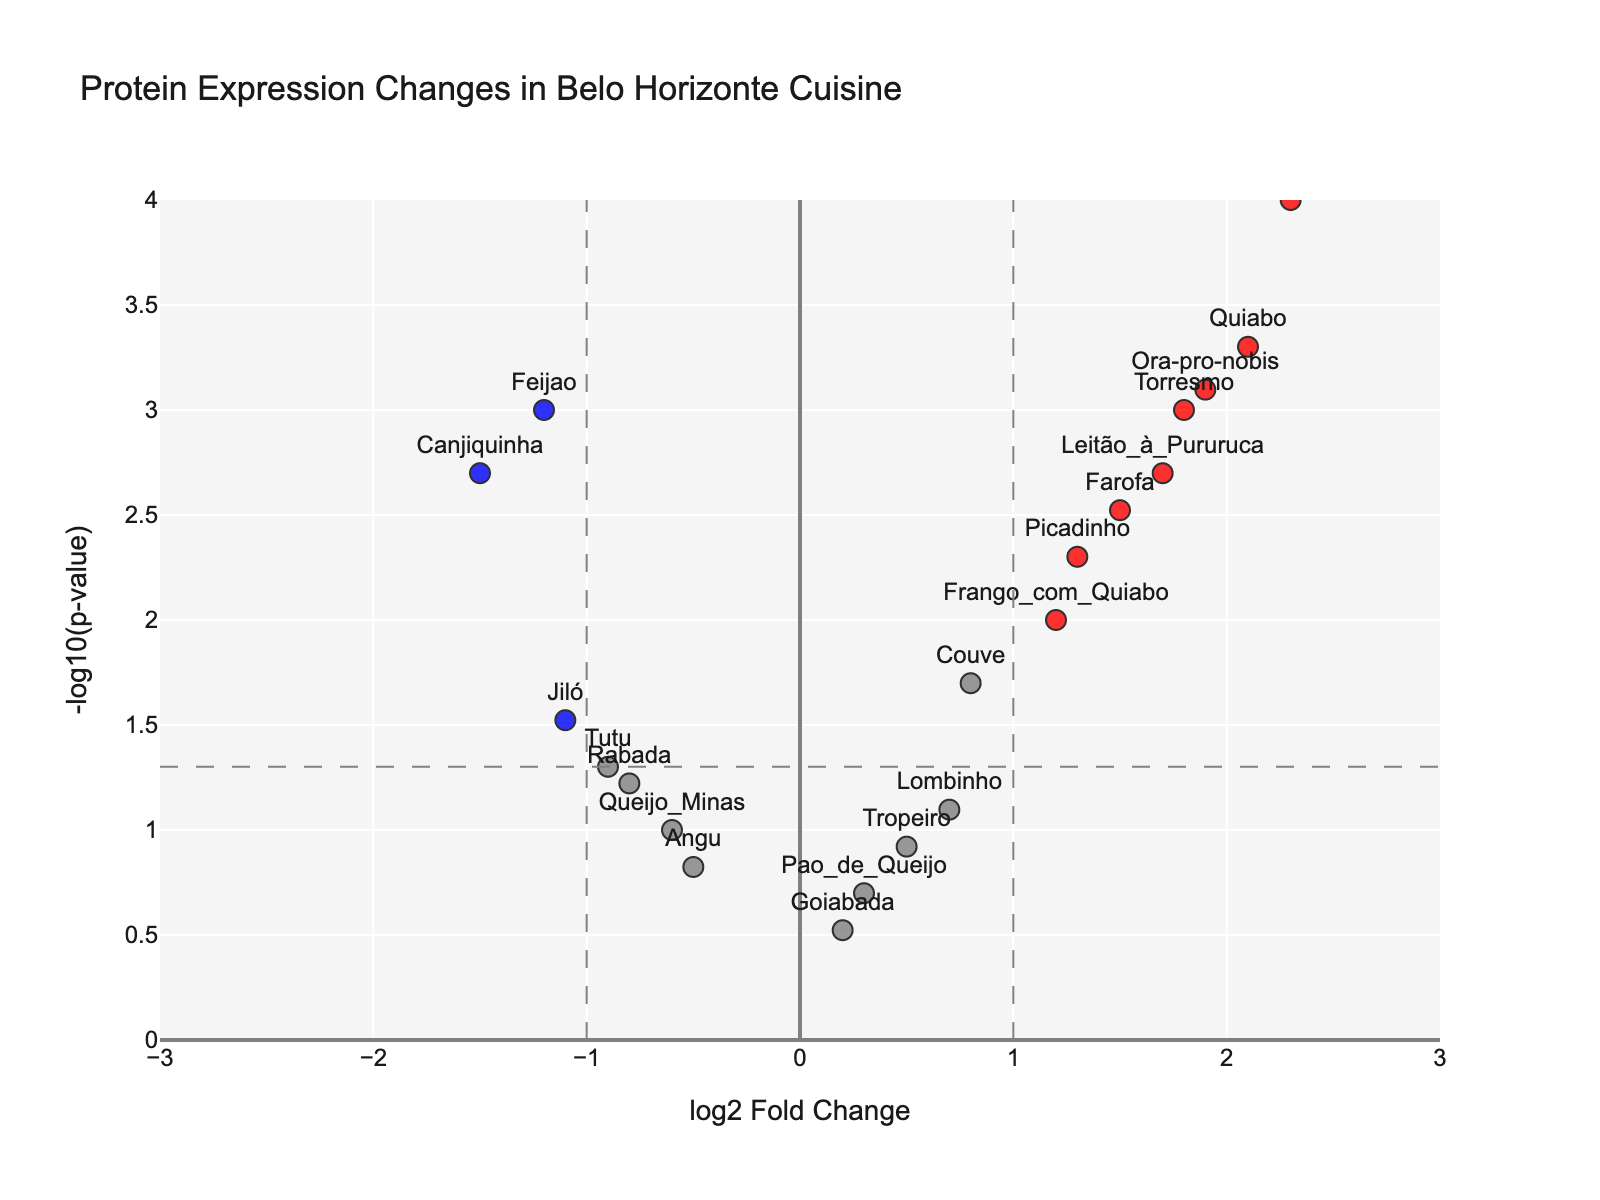What is the title of the figure? The title is typically positioned at the top of the figure and can be read directly. In this case, it's specifically provided in the layout of the plot.
Answer: Protein Expression Changes in Belo Horizonte Cuisine What protein shows the highest log2 fold change? The highest log2 fold change can be identified by looking at the data point farthest to the right on the x-axis. This corresponds to "Feijoada" with a log2 fold change of 2.3.
Answer: Feijoada How many proteins are marked in red? Proteins marked in red indicate significant changes with a log2 fold change greater than the threshold and a p-value below the threshold. By counting these data points on the plot, we identify them.
Answer: 6 Which protein has the lowest p-value? The lowest p-value corresponds to the data point with the highest value on the y-axis (-log10(p-value)). This is "Feijoada" with a p-value of 0.0001.
Answer: Feijoada What is the fold change of "Feijao"? The fold change of "Feijao" is its log2FoldChange value, which can be directly observed from the plot or data. "Feijao" is located at -1.2.
Answer: -1.2 How many proteins have a log2 fold change less than -1 and are statistically significant? Proteins meeting these criteria will be located in the blue region far left of the x-axis and have a -log10(p-value) above the threshold line. By counting these data points, we realize there are two: "Canjiquinha" and "Feijao".
Answer: 2 Which proteins fall into the category of having a log2 fold change greater than 1 and a p-value less than 0.01? Proteins in this category will be marked in red and fall to the right of the threshold line. By checking the log2 fold change and p-values, we identify "Quiabo", "Torresmo", "Ora-pro-nobis", "Leitão_à_Pururuca", and "Feijoada".
Answer: Quiabo, Torresmo, Ora-pro-nobis, Leitão_à_Pururuca, Feijoada Are there any proteins with a log2 fold change of exactly 0? A log2 fold change of 0 would be positioned at the center on the x-axis, but there are no data points exactly at this location.
Answer: No Which protein has the highest -log10(pValue) without being statistically significant? A statistically significant value would be above the threshold line, so we search for the highest point just below this line, which corresponds to the protein with the highest -log10(pValue) not in red or blue. "Jiló" fits this criterion with a -log10(pValue) of approximately 1.52.
Answer: Jiló 